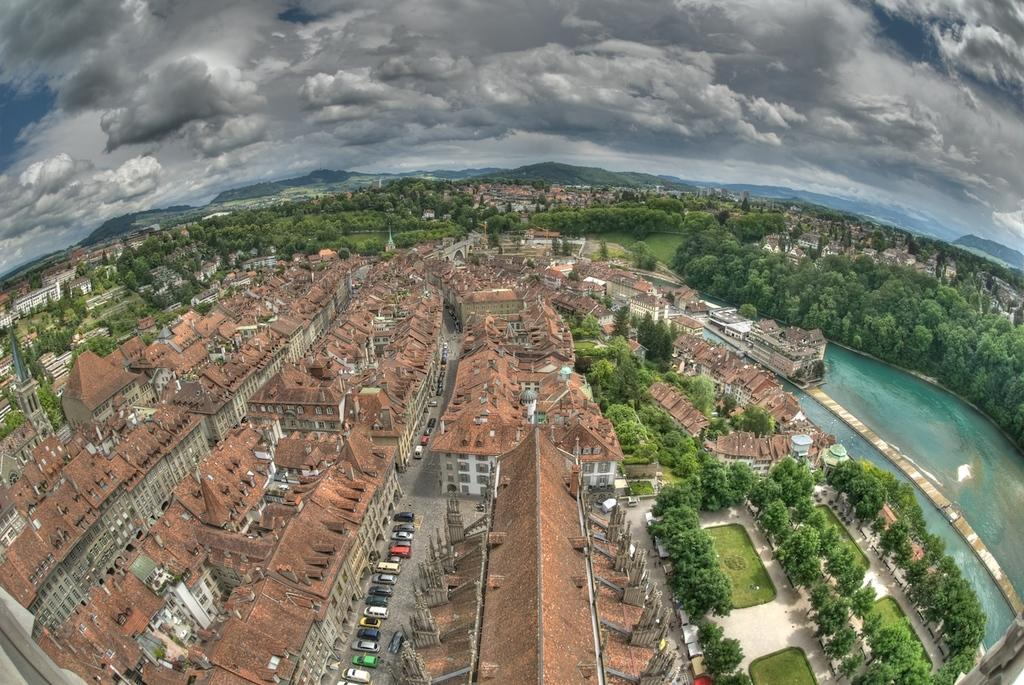What type of structures can be seen in the image? There are buildings in the image. What vehicles are present in the image? There are cars in the image. What type of vegetation can be seen in the image? There are plants and trees in the image. What geographical features are visible in the image? There are mountains in the image. What natural element is visible in the image? There is water visible in the image. What is the condition of the sky in the image? The sky is cloudy in the image. What type of ground cover is present in the image? There is grass on the ground in the image. Where is the lamp located in the image? There is no lamp present in the image. What type of ornament is hanging from the trees in the image? There are no ornaments hanging from the trees in the image. 